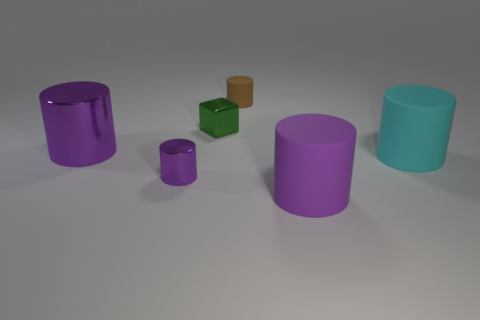What number of cylinders are both to the left of the cyan matte cylinder and to the right of the green thing?
Your response must be concise. 2. There is a big object that is in front of the cyan thing; what is its shape?
Give a very brief answer. Cylinder. How many small green things have the same material as the small brown object?
Keep it short and to the point. 0. There is a large cyan thing; is it the same shape as the matte thing behind the tiny green shiny object?
Offer a terse response. Yes. Are there any big objects in front of the big purple object in front of the large purple cylinder to the left of the green object?
Offer a very short reply. No. What is the size of the object that is in front of the tiny purple shiny thing?
Give a very brief answer. Large. What material is the cube that is the same size as the brown matte thing?
Provide a short and direct response. Metal. Does the tiny brown rubber thing have the same shape as the purple matte thing?
Make the answer very short. Yes. What number of things are either tiny brown cylinders or large things that are to the left of the brown cylinder?
Offer a terse response. 2. What is the material of the tiny cylinder that is the same color as the big metal cylinder?
Provide a succinct answer. Metal. 